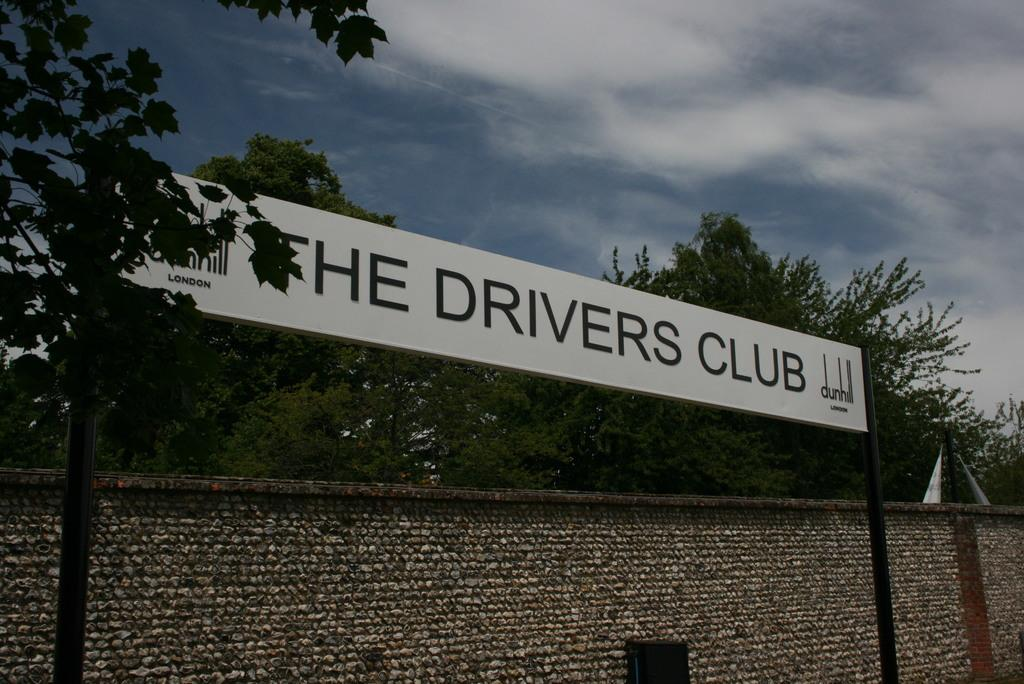What is the main structure visible in the image? There is a wall in the image. What is attached to the wall in the image? There is a board attached to poles in front of the wall. What can be seen on the board? There is text on the board. What is visible behind the wall in the image? There are trees behind the wall. What is visible at the top of the image? The sky is visible at the top of the image. How does the calculator help with the sailing in the image? There is no calculator or sailing activity present in the image. 